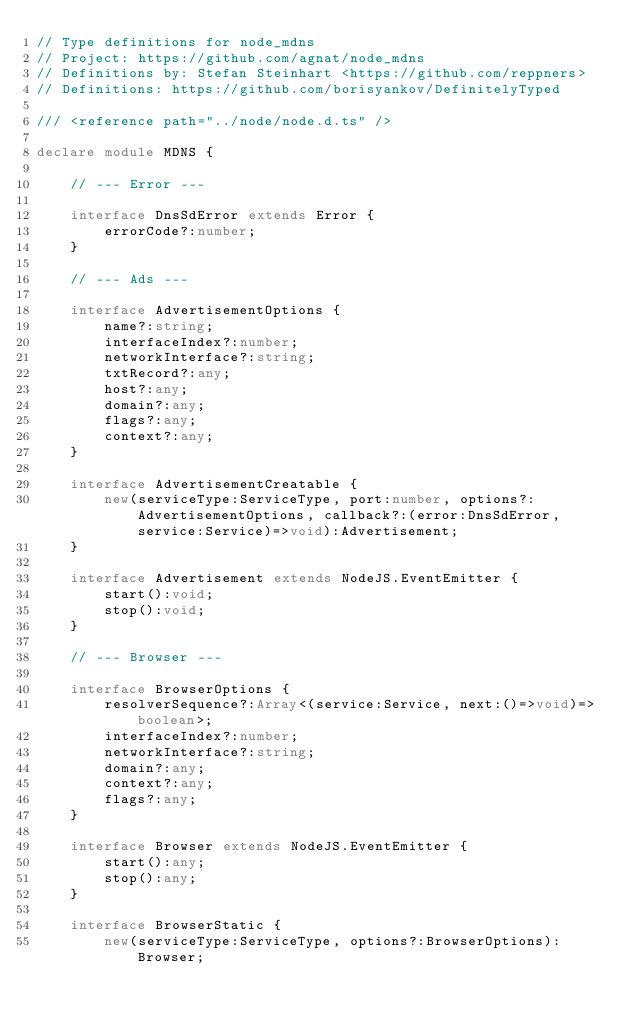Convert code to text. <code><loc_0><loc_0><loc_500><loc_500><_TypeScript_>// Type definitions for node_mdns
// Project: https://github.com/agnat/node_mdns
// Definitions by: Stefan Steinhart <https://github.com/reppners>
// Definitions: https://github.com/borisyankov/DefinitelyTyped

/// <reference path="../node/node.d.ts" />

declare module MDNS {

    // --- Error ---

    interface DnsSdError extends Error {
        errorCode?:number;
    }

    // --- Ads ---

    interface AdvertisementOptions {
        name?:string;
        interfaceIndex?:number;
        networkInterface?:string;
        txtRecord?:any;
        host?:any;
        domain?:any;
        flags?:any;
        context?:any;
    }

    interface AdvertisementCreatable {
        new(serviceType:ServiceType, port:number, options?:AdvertisementOptions, callback?:(error:DnsSdError, service:Service)=>void):Advertisement;
    }

    interface Advertisement extends NodeJS.EventEmitter {
        start():void;
        stop():void;
    }

    // --- Browser ---

    interface BrowserOptions {
        resolverSequence?:Array<(service:Service, next:()=>void)=>boolean>;
        interfaceIndex?:number;
        networkInterface?:string;
        domain?:any;
        context?:any;
        flags?:any;
    }

    interface Browser extends NodeJS.EventEmitter {
        start():any;
        stop():any;
    }

    interface BrowserStatic {
        new(serviceType:ServiceType, options?:BrowserOptions):Browser;</code> 